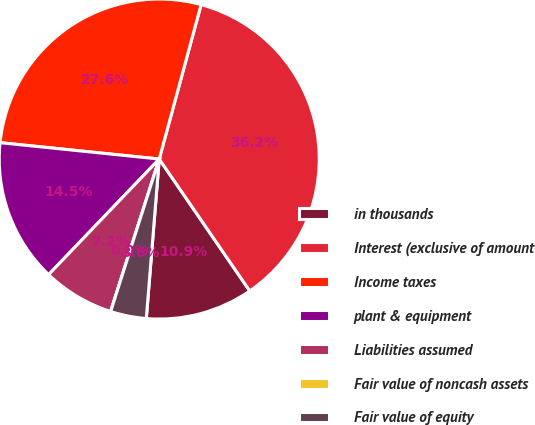Convert chart to OTSL. <chart><loc_0><loc_0><loc_500><loc_500><pie_chart><fcel>in thousands<fcel>Interest (exclusive of amount<fcel>Income taxes<fcel>plant & equipment<fcel>Liabilities assumed<fcel>Fair value of noncash assets<fcel>Fair value of equity<nl><fcel>10.86%<fcel>36.21%<fcel>27.58%<fcel>14.48%<fcel>7.24%<fcel>0.0%<fcel>3.62%<nl></chart> 